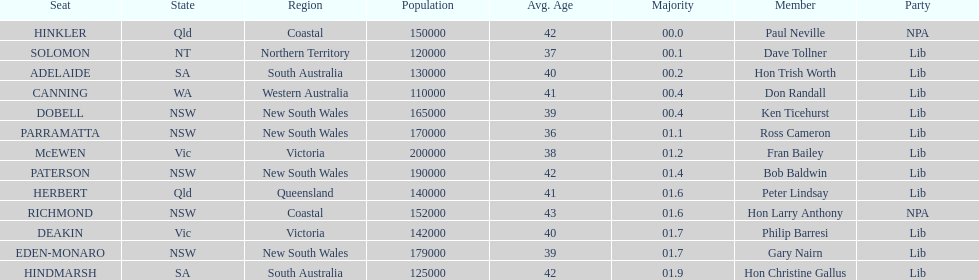What was the total majority that the dobell seat had? 00.4. 